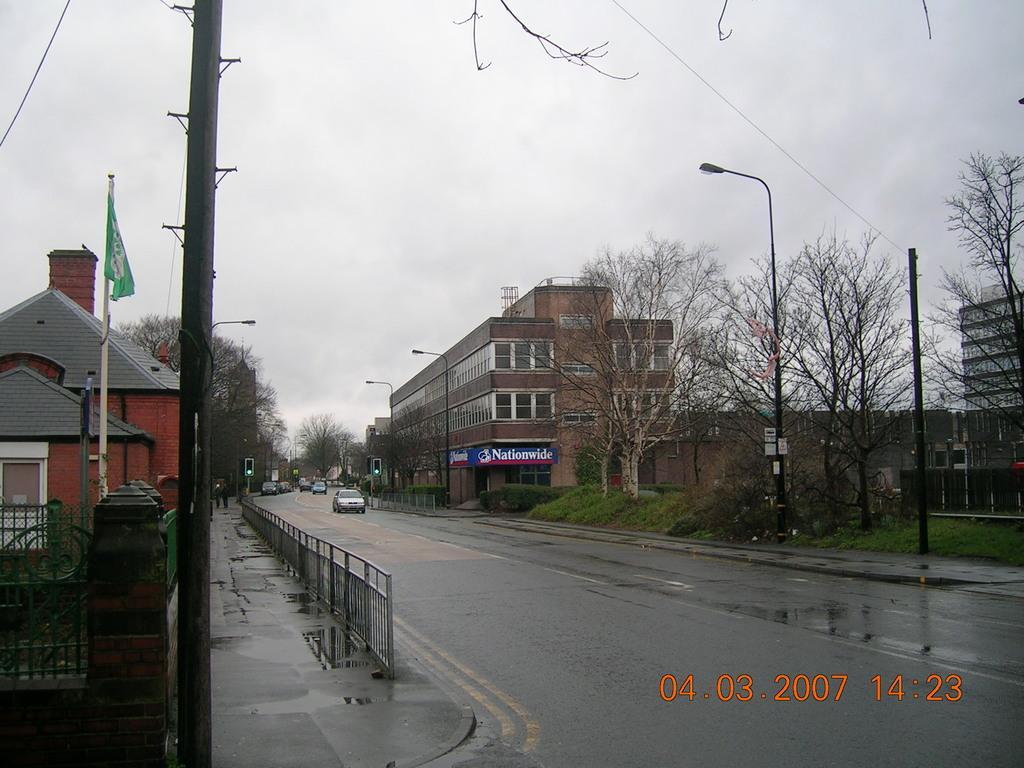In one or two sentences, can you explain what this image depicts? In the image we can see there are buildings and trees. We can even see there are vehicles on the road. Here we can see the fence, poles and the cloudy sky. We can see the road is wet and on the bottom right we can see the watermark. 